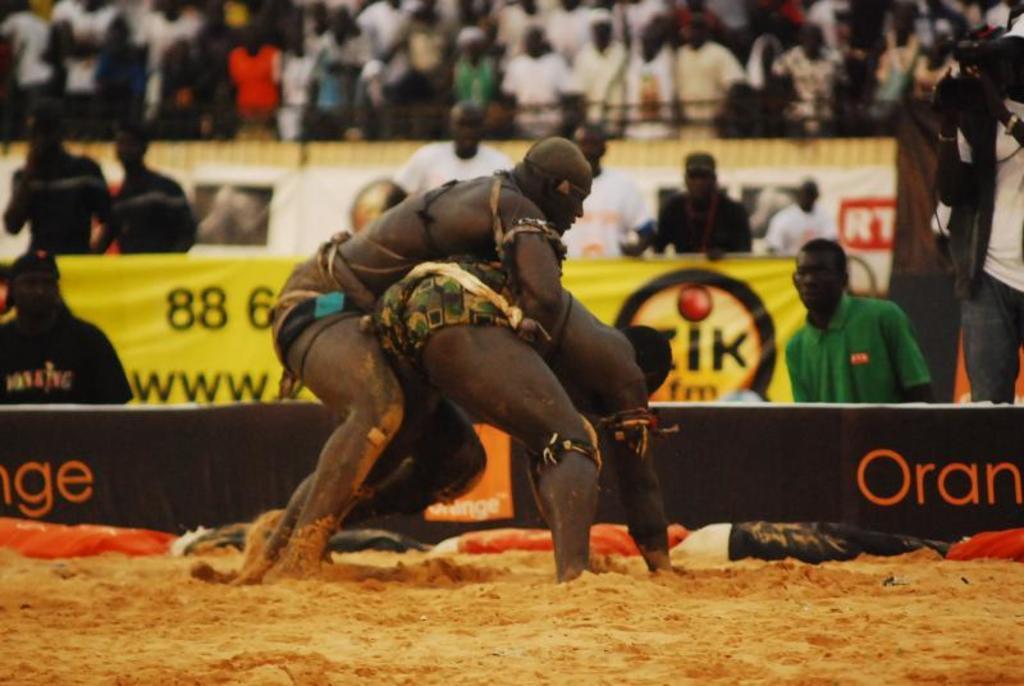Please provide a concise description of this image. In this image I can see a person is grabbing another person. In the background I can see group of people and banners on which I can see some logos. On the right side I can see a person is holding video camera in the hand. 